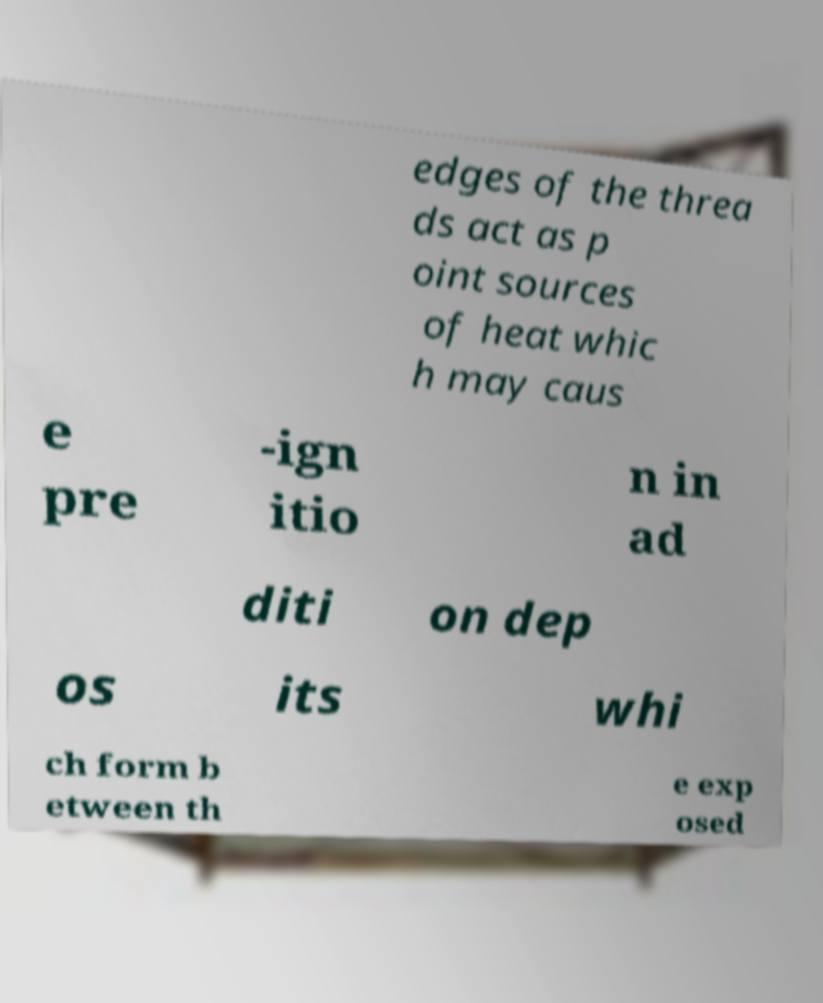What messages or text are displayed in this image? I need them in a readable, typed format. edges of the threa ds act as p oint sources of heat whic h may caus e pre -ign itio n in ad diti on dep os its whi ch form b etween th e exp osed 